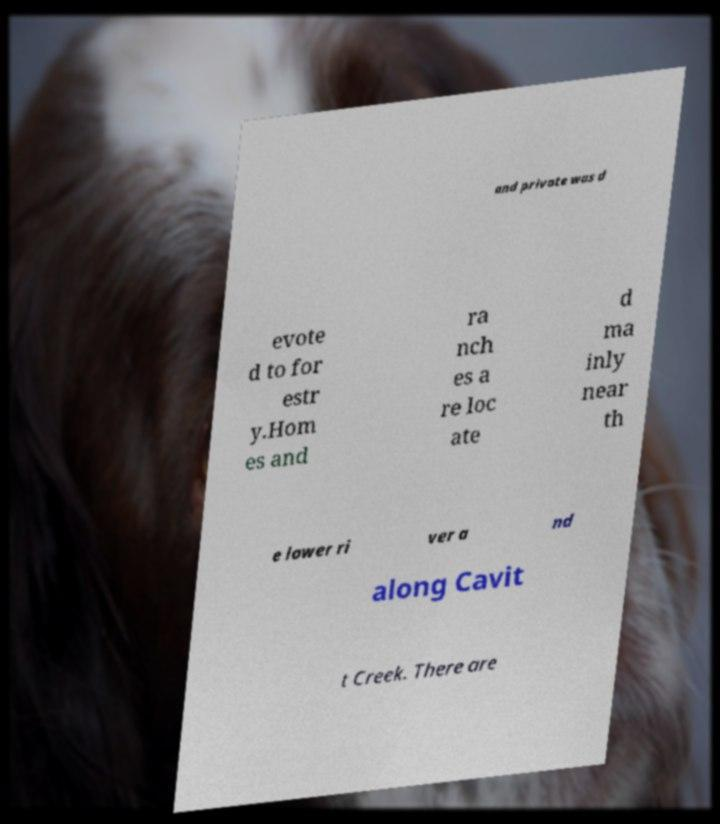For documentation purposes, I need the text within this image transcribed. Could you provide that? and private was d evote d to for estr y.Hom es and ra nch es a re loc ate d ma inly near th e lower ri ver a nd along Cavit t Creek. There are 